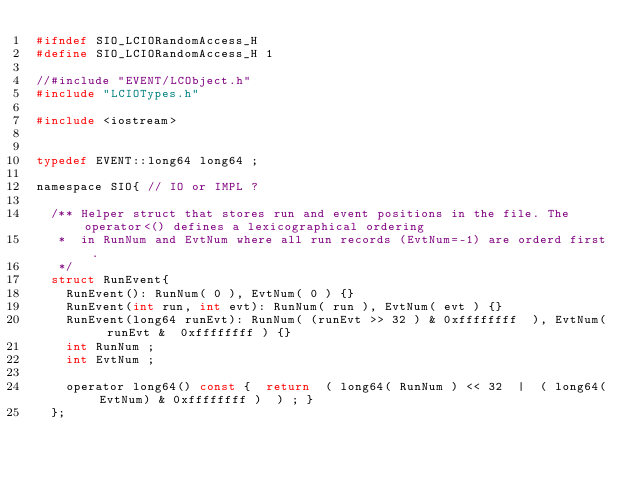Convert code to text. <code><loc_0><loc_0><loc_500><loc_500><_C_>#ifndef SIO_LCIORandomAccess_H
#define SIO_LCIORandomAccess_H 1

//#include "EVENT/LCObject.h"
#include "LCIOTypes.h"

#include <iostream>


typedef EVENT::long64 long64 ;

namespace SIO{ // IO or IMPL ?

  /** Helper struct that stores run and event positions in the file. The operator<() defines a lexicographical ordering
   *  in RunNum and EvtNum where all run records (EvtNum=-1) are orderd first. 
   */
  struct RunEvent{
    RunEvent(): RunNum( 0 ), EvtNum( 0 ) {}
    RunEvent(int run, int evt): RunNum( run ), EvtNum( evt ) {}
    RunEvent(long64 runEvt): RunNum( (runEvt >> 32 ) & 0xffffffff  ), EvtNum( runEvt &  0xffffffff ) {}
    int RunNum ;
    int EvtNum ;
    
    operator long64() const {  return  ( long64( RunNum ) << 32  |  ( long64(EvtNum) & 0xffffffff )  ) ; } 
  };
  </code> 